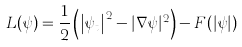Convert formula to latex. <formula><loc_0><loc_0><loc_500><loc_500>L ( \psi ) = \frac { 1 } { 2 } \left ( \left | \psi _ { t } \right | ^ { 2 } - | \nabla \psi | ^ { 2 } \right ) - F ( | \psi | )</formula> 